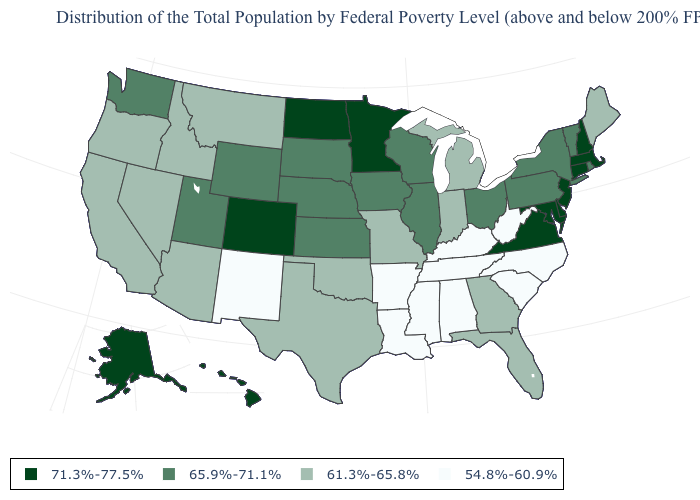Which states have the lowest value in the USA?
Quick response, please. Alabama, Arkansas, Kentucky, Louisiana, Mississippi, New Mexico, North Carolina, South Carolina, Tennessee, West Virginia. Among the states that border New Hampshire , which have the highest value?
Keep it brief. Massachusetts. Among the states that border South Dakota , does Minnesota have the highest value?
Short answer required. Yes. Which states hav the highest value in the MidWest?
Be succinct. Minnesota, North Dakota. Does New Jersey have the highest value in the Northeast?
Write a very short answer. Yes. What is the value of Massachusetts?
Concise answer only. 71.3%-77.5%. What is the value of Mississippi?
Be succinct. 54.8%-60.9%. What is the value of Ohio?
Keep it brief. 65.9%-71.1%. How many symbols are there in the legend?
Quick response, please. 4. Name the states that have a value in the range 65.9%-71.1%?
Short answer required. Illinois, Iowa, Kansas, Nebraska, New York, Ohio, Pennsylvania, Rhode Island, South Dakota, Utah, Vermont, Washington, Wisconsin, Wyoming. Among the states that border Texas , does Louisiana have the lowest value?
Be succinct. Yes. Does the first symbol in the legend represent the smallest category?
Be succinct. No. Among the states that border North Carolina , which have the highest value?
Be succinct. Virginia. What is the lowest value in the USA?
Quick response, please. 54.8%-60.9%. Name the states that have a value in the range 71.3%-77.5%?
Give a very brief answer. Alaska, Colorado, Connecticut, Delaware, Hawaii, Maryland, Massachusetts, Minnesota, New Hampshire, New Jersey, North Dakota, Virginia. 